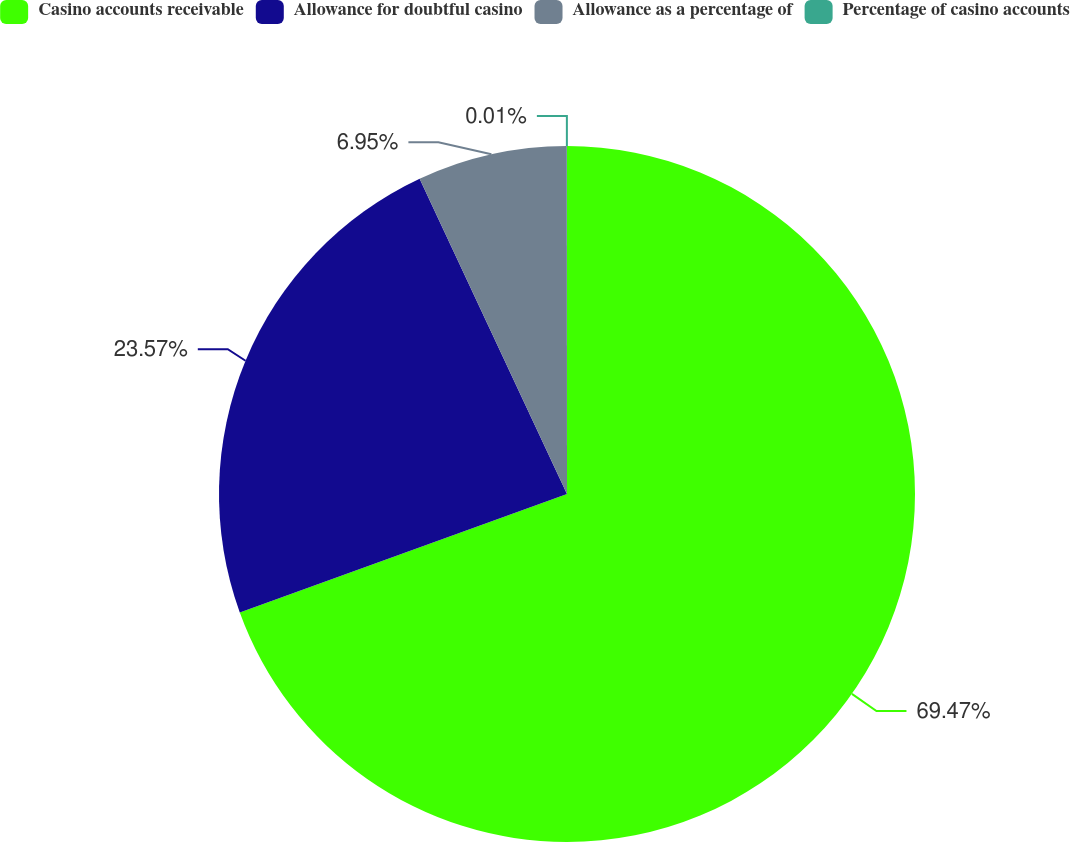<chart> <loc_0><loc_0><loc_500><loc_500><pie_chart><fcel>Casino accounts receivable<fcel>Allowance for doubtful casino<fcel>Allowance as a percentage of<fcel>Percentage of casino accounts<nl><fcel>69.47%<fcel>23.57%<fcel>6.95%<fcel>0.01%<nl></chart> 